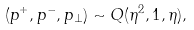Convert formula to latex. <formula><loc_0><loc_0><loc_500><loc_500>( p ^ { + } , p ^ { - } , p _ { \perp } ) \sim Q ( \eta ^ { 2 } , 1 , \eta ) ,</formula> 